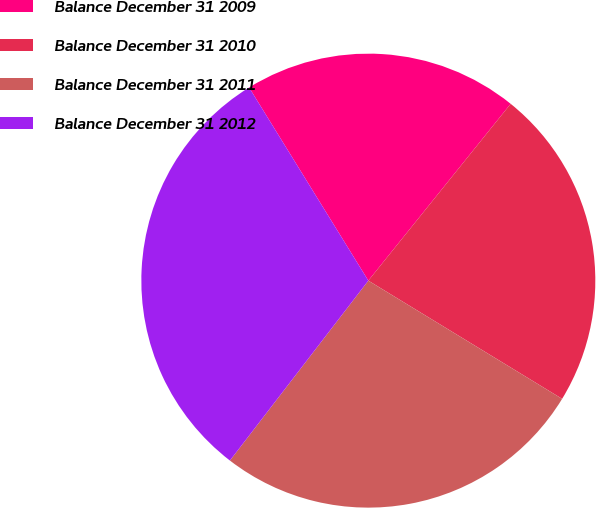Convert chart. <chart><loc_0><loc_0><loc_500><loc_500><pie_chart><fcel>Balance December 31 2009<fcel>Balance December 31 2010<fcel>Balance December 31 2011<fcel>Balance December 31 2012<nl><fcel>19.59%<fcel>22.93%<fcel>26.72%<fcel>30.76%<nl></chart> 